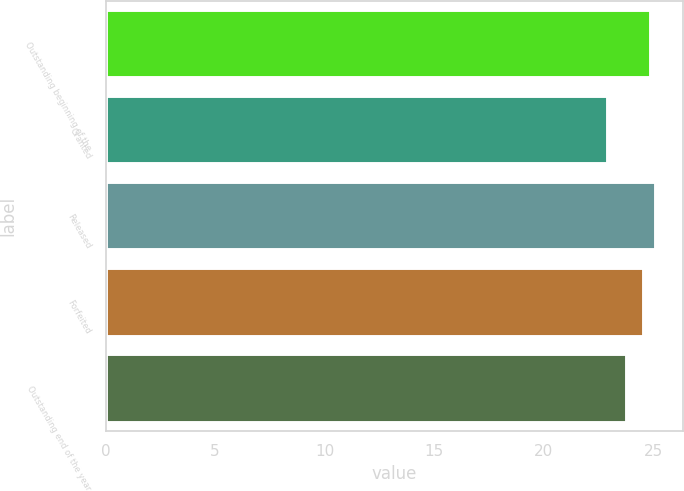<chart> <loc_0><loc_0><loc_500><loc_500><bar_chart><fcel>Outstanding beginning of the<fcel>Granted<fcel>Released<fcel>Forfeited<fcel>Outstanding end of the year<nl><fcel>24.91<fcel>22.92<fcel>25.13<fcel>24.6<fcel>23.79<nl></chart> 